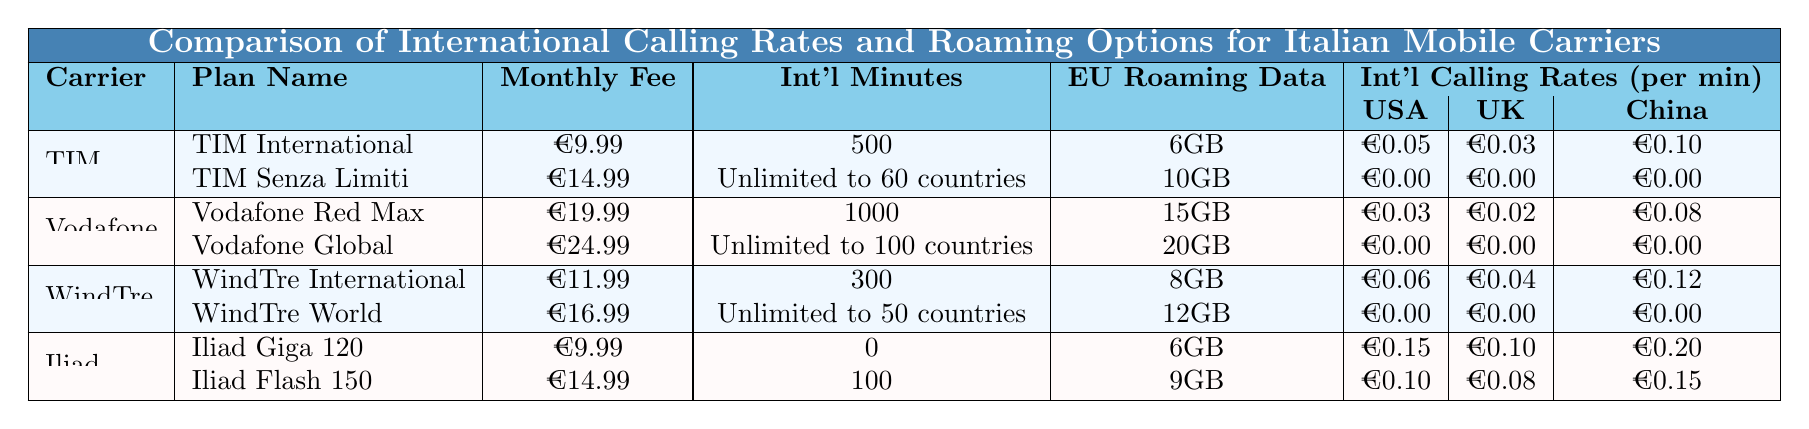What is the monthly fee for the TIM Senza Limiti plan? The table lists the TIM Senza Limiti plan under the TIM carrier, where the monthly fee is stated as €14.99.
Answer: €14.99 Which carrier offers the highest number of international minutes? By comparing the plans listed in the table, Vodafone Red Max offers 1000 international minutes, which is higher than the other options.
Answer: Vodafone Red Max Does Iliad offer any plans with unlimited international minutes? Looking at the table, Iliad's plans do not include any option for unlimited international minutes, indicating that the answer is no.
Answer: No What is the total amount of roaming data offered by WindTre in their plans? WindTre offers 8GB in the WindTre International plan and 12GB in the WindTre World plan. Adding these values gives a total of 8GB + 12GB = 20GB.
Answer: 20GB Which plan has the lowest rate per minute for calls to the USA? The TIM Senza Limiti plan has a rate of €0.00 per minute for calls to the USA, and other plans have higher rates, indicating this is the lowest.
Answer: TIM Senza Limiti Compare the EU roaming data offered by Iliad's two plans. Iliad Giga 120 offers 6GB while Iliad Flash 150 offers 9GB for EU roaming data. Thus, Iliad Flash 150 has more data than Iliad Giga 120.
Answer: Iliad Flash 150 offers more What is the average monthly fee of Vodafone's plans? The Vodafone plans have monthly fees of €19.99 and €24.99. We calculate the average: (€19.99 + €24.99) / 2 = €22.49.
Answer: €22.49 Is it true that all plans from Vodafone provide free calling rates to the specified destinations? The table indicates that Vodafone Global and Vodafone Red Max have a calling rate of €0.00 for USA, UK, and China, confirming that the statement is true.
Answer: Yes How do the international calling rates for the UK compare between the TIM and WindTre carriers? TIM charges €0.03 per minute for calls to the UK, while WindTre charges €0.04 per minute. Thus, TIM offers a cheaper rate compared to WindTre.
Answer: TIM charges less What is the difference in monthly fees between Iliad's two plans? The monthly fees for Iliad's plans are €9.99 for Iliad Giga 120 and €14.99 for Iliad Flash 150. The difference is €14.99 - €9.99 = €5.00.
Answer: €5.00 Which carrier's plan allows calls to both the USA and UK for free? Both the TIM Senza Limiti and Vodafone Global plans allow calls to the USA and UK for free, marked with a rate of €0.00 for these destinations.
Answer: TIM Senza Limiti and Vodafone Global 